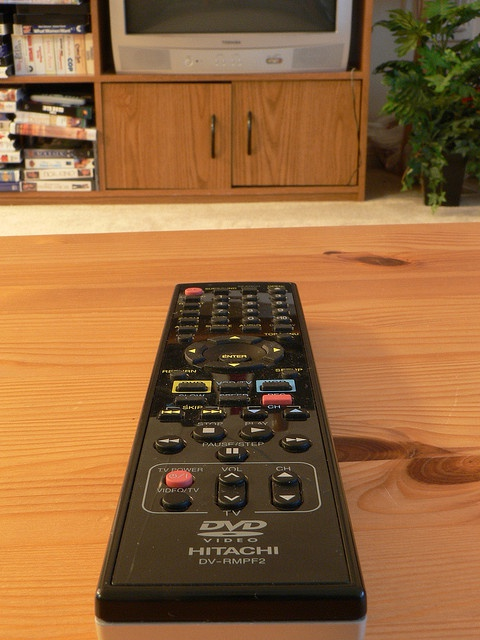Describe the objects in this image and their specific colors. I can see remote in darkgray, black, maroon, and brown tones, tv in darkgray, tan, and black tones, potted plant in darkgray, black, darkgreen, and maroon tones, book in darkgray, black, and tan tones, and book in darkgray and tan tones in this image. 